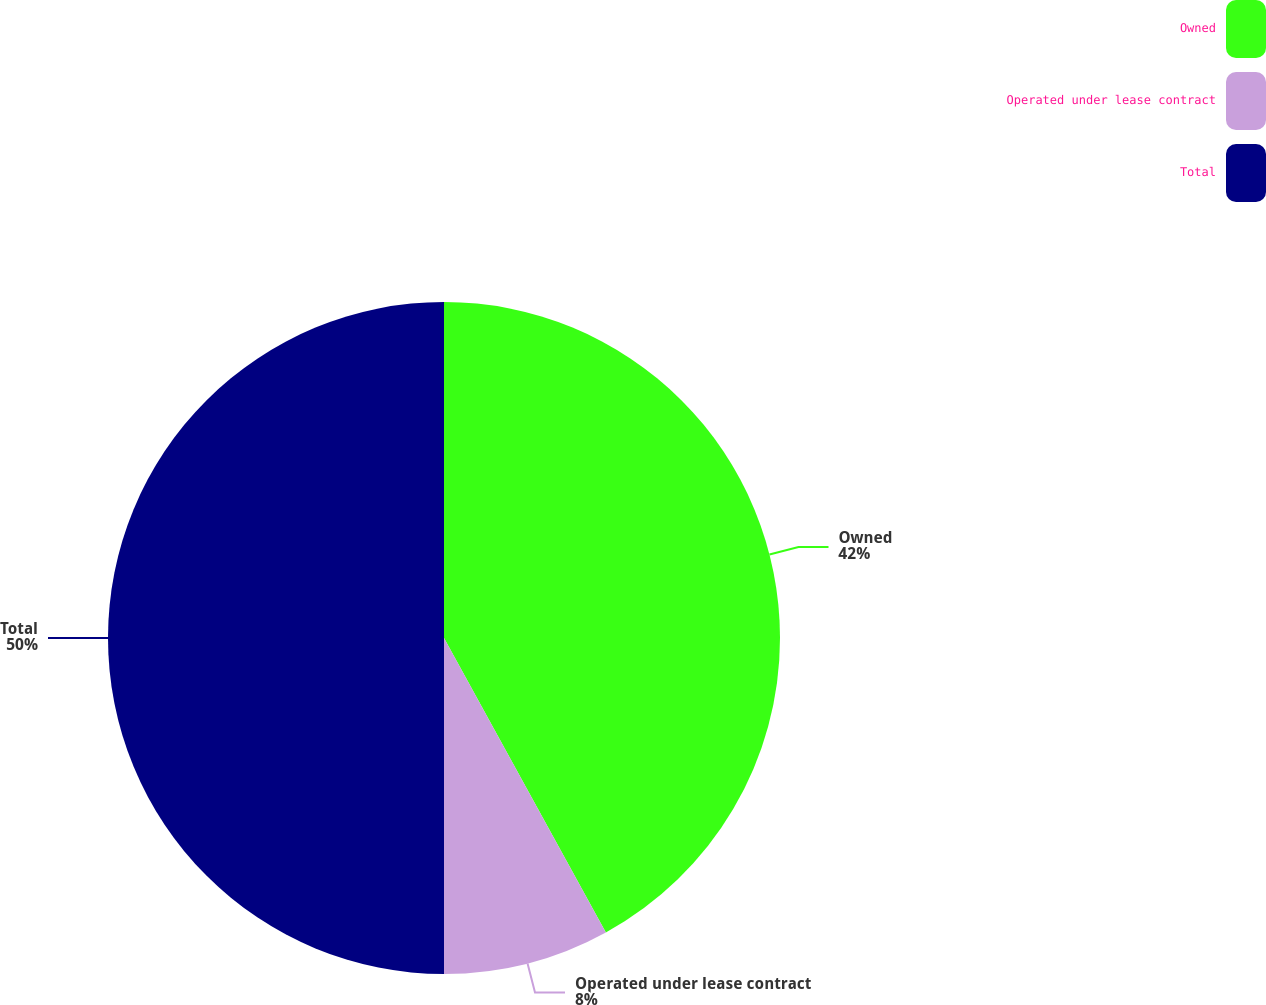<chart> <loc_0><loc_0><loc_500><loc_500><pie_chart><fcel>Owned<fcel>Operated under lease contract<fcel>Total<nl><fcel>42.0%<fcel>8.0%<fcel>50.0%<nl></chart> 